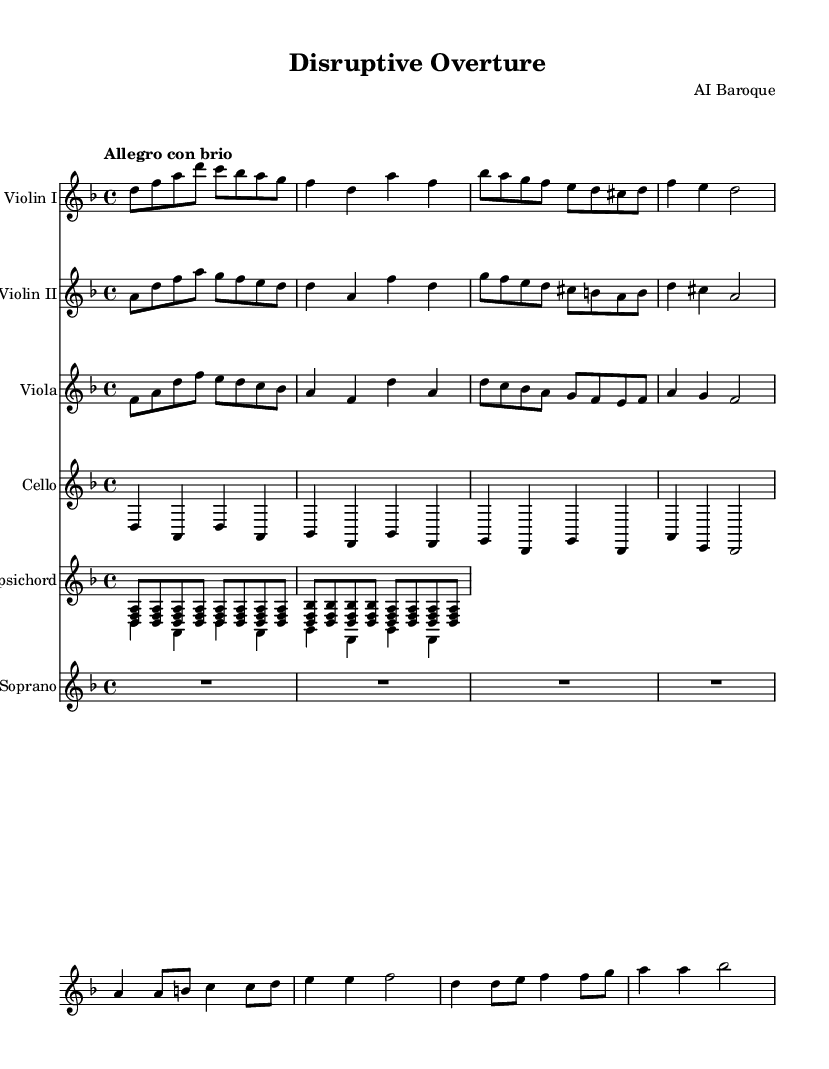What is the key signature of this music? The key signature indicates D minor, which has one flat (B flat). It can be found at the beginning of the staff, showing the specific notes that are altered.
Answer: D minor What is the time signature of this music? The time signature is 4/4, as indicated at the beginning of the score. This means there are four beats in each measure and the quarter note receives one beat.
Answer: 4/4 What is the tempo marking for this piece? The tempo marking is "Allegro con brio," suggesting a fast and lively tempo with vigor. This is indicated above the score.
Answer: Allegro con brio How many measures are present in the music? By counting each instance of the bar lines in the sheet music, we can see that there are a total of 8 measures present.
Answer: 8 Which instrument plays the highest pitch in this excerpt? The Soprano part contains the highest pitches compared to the other instruments, as it is written in the treble clef. The melodies are typically sung above the harmonic accompaniment.
Answer: Soprano What thematic element do the lyrics of the soprano address? The lyrics reflect themes of change and transformation, as they express ideas of old structures crumbling and new ones rising. This is a demonstration of societal transformation, which can be inferred from the text's content.
Answer: Change What is the role of the harpsichord in this piece? The harpsichord serves as the continuo, providing harmonic support and rhythm critical in Baroque music, indicated by its independent staff playing chords.
Answer: Continuo 